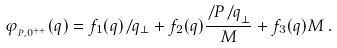Convert formula to latex. <formula><loc_0><loc_0><loc_500><loc_500>\varphi _ { _ { P , 0 ^ { + + } } } ( q ) = f _ { 1 } ( q ) { \not \, q _ { \perp } } + f _ { 2 } ( q ) \frac { { \not \, P } { \not \, q } _ { \perp } } { M } + f _ { 3 } ( q ) M \, .</formula> 